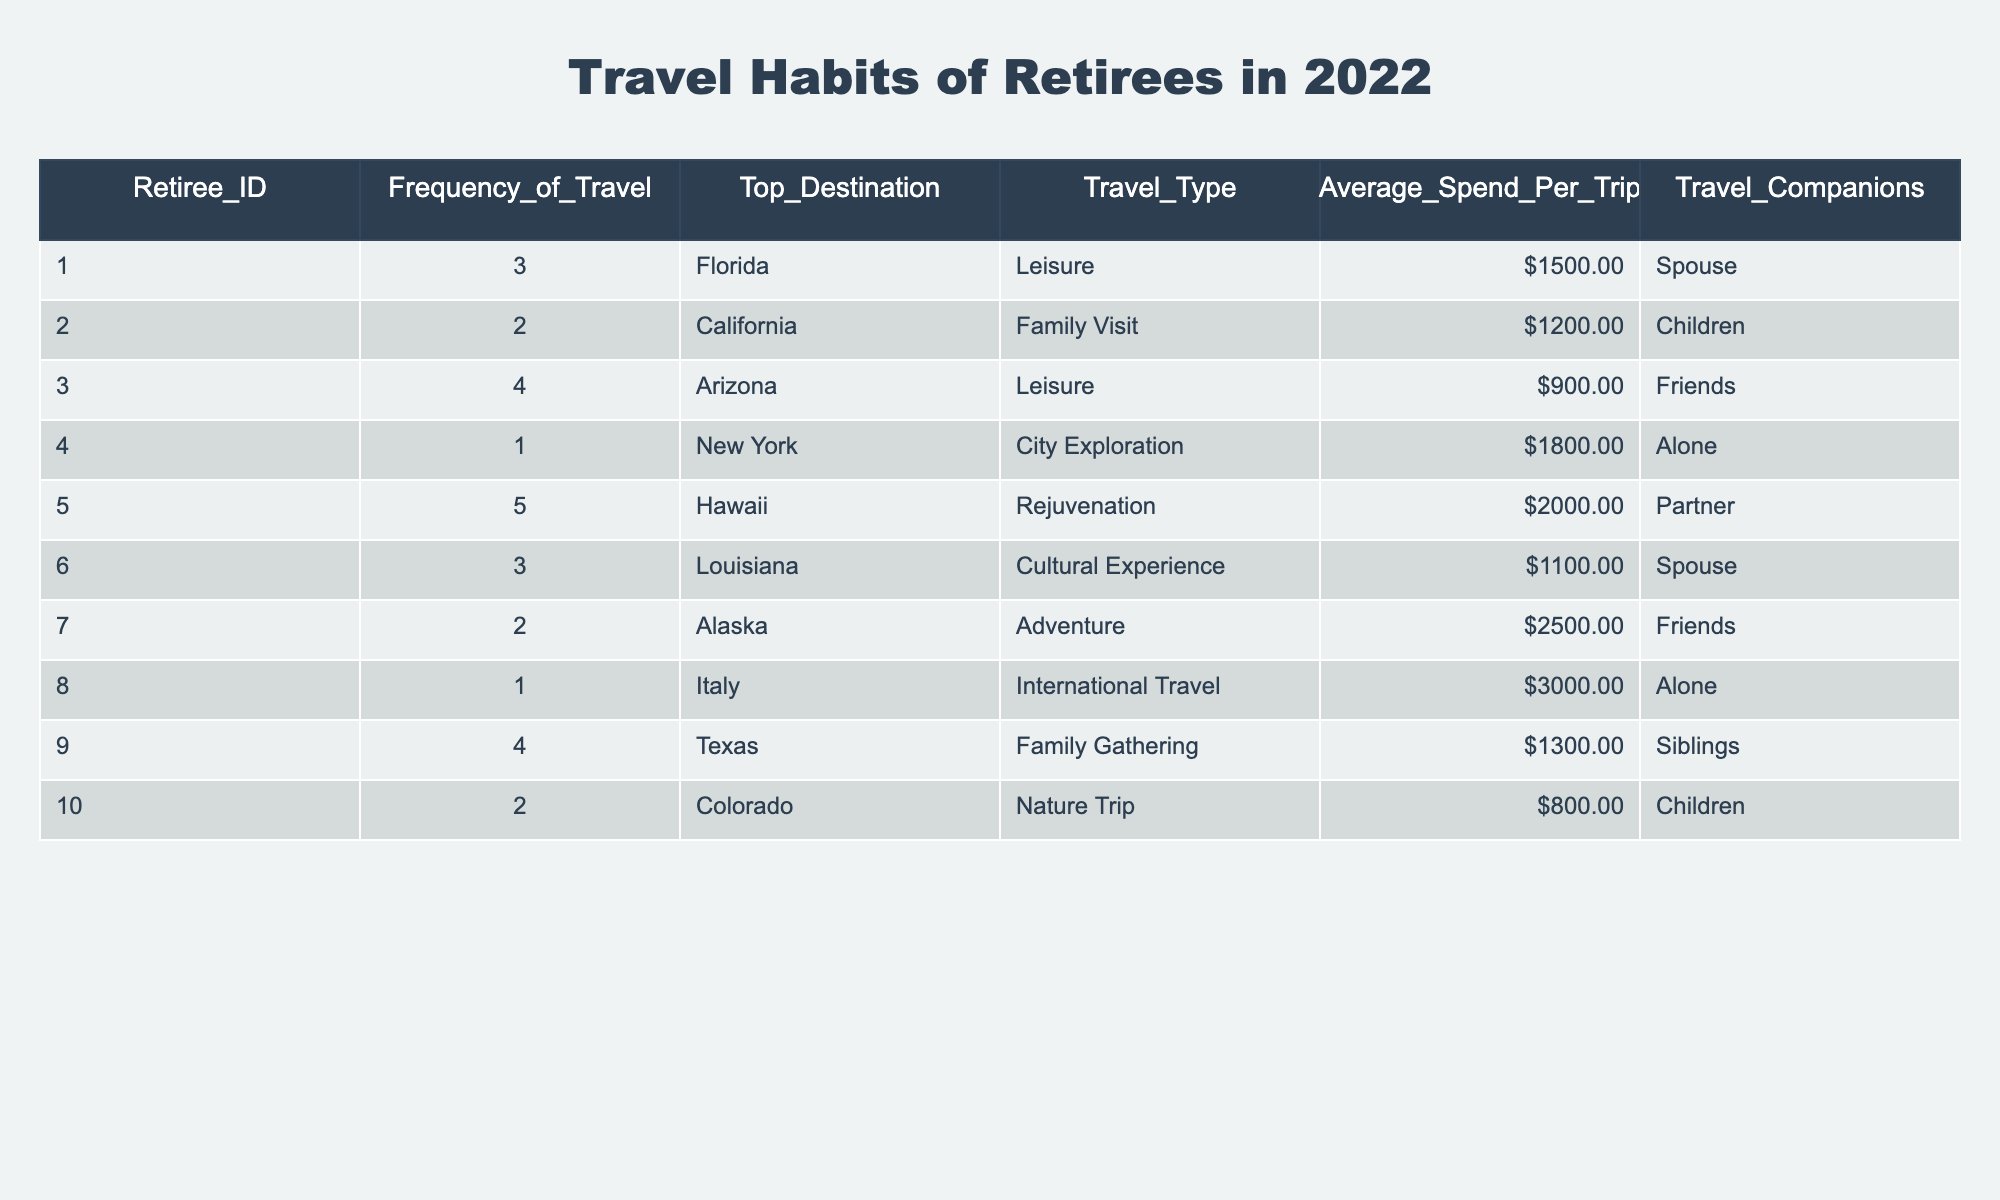What is the top destination for retirees who travel the most frequently? Referring to the table, retiree ID 5 travels 5 times and lists Hawaii as the top destination.
Answer: Hawaii How many retirees traveled to Alaska? The table shows that retiree ID 7 traveled to Alaska, and there are no other entries for that destination, so only one retiree traveled there.
Answer: 1 What is the average spend per trip for retirees traveling for leisure? To find this, we look for all entries with the travel type 'Leisure': retirees 1, 3, and 5 spent 1500, 900, and 2000 respectively. The average is calculated as (1500 + 900 + 2000) / 3 = 1200.
Answer: 1200 Did any retirees travel alone? Looking through the table, retiree IDs 4 and 8 both indicate "Alone" under the Travel Companions column, confirming that there are retirees who traveled alone.
Answer: Yes Which retiree had the highest average spend per trip? Analyzing the Average Spend Per Trip column, the highest value is 3000 from retiree ID 8.
Answer: 3000 What is the total frequency of travel for retirees who visit family? The table shows two retirees (IDs 2 and 9) who traveled for family visits. Each traveled either 2 or 4 times, totaling 2 + 4 = 6 for combined frequency.
Answer: 6 Is there a retiree who spent more than 2500 per trip? Reviewing the Average Spend Per Trip column, retiree ID 8 spent 3000 and retiree ID 7 spent 2500, confirming at least one retiree spent more than 2500.
Answer: Yes What percentage of retirees traveled to international destinations? Only retiree ID 8 traveled to an international destination (Italy), out of 10 total retirees, so the percentage is (1/10) * 100 = 10%.
Answer: 10% Which travel type had the least average spend, and what was that amount? The travel types and their averages are Leisure (1200), Family Visit (1200), Cultural Experience (1100), City Exploration (1800), Adventure (2500), and Nature Trip (800). Nature Trip has the least average at 800.
Answer: 800 